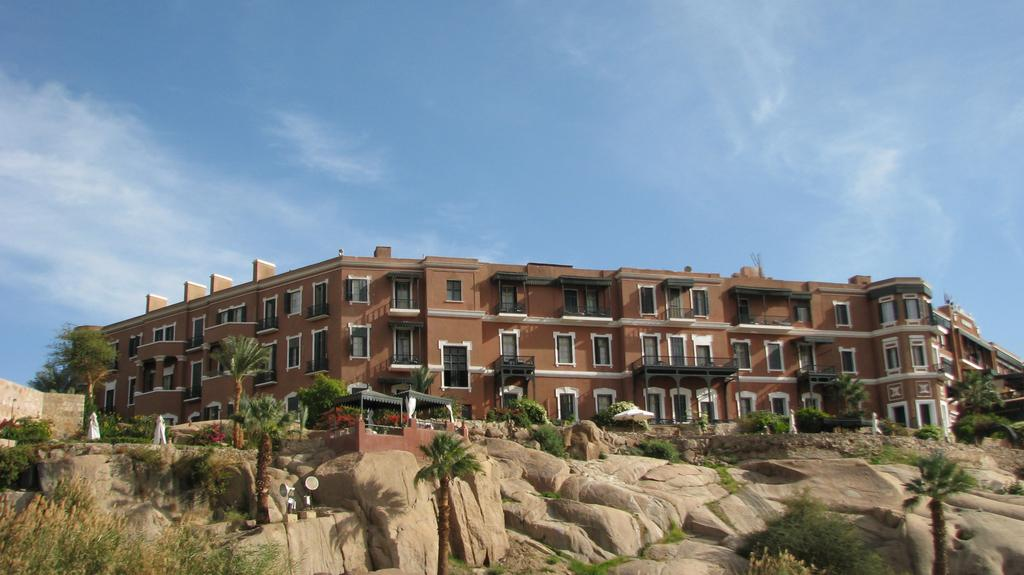What is the main structure in the image? There is a big brown color building in the image. What color are the windows of the building? The building has white window glass. What is located in front of the building? There is a rock mountain in front of the building. What type of vegetation is present in the image? There are coconut trees in the image. How many kittens are playing with a match near the building in the image? There are no kittens or matches present in the image. 